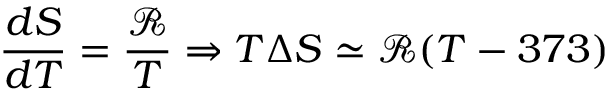<formula> <loc_0><loc_0><loc_500><loc_500>\frac { d S } { d T } = \frac { \mathcal { R } } { T } \Rightarrow T \Delta S \simeq \mathcal { R } ( T - 3 7 3 )</formula> 